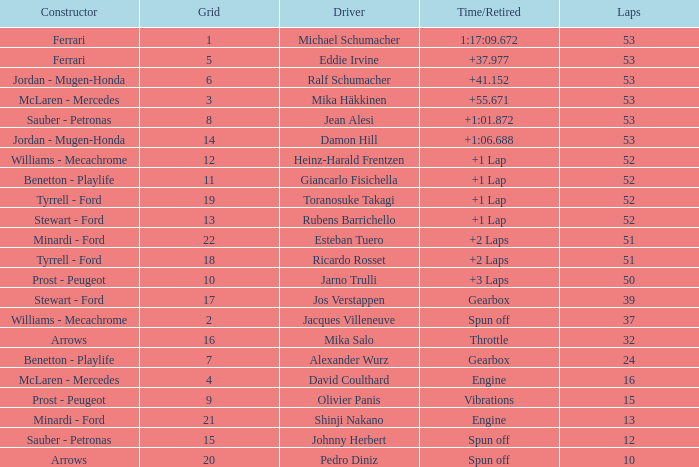Would you be able to parse every entry in this table? {'header': ['Constructor', 'Grid', 'Driver', 'Time/Retired', 'Laps'], 'rows': [['Ferrari', '1', 'Michael Schumacher', '1:17:09.672', '53'], ['Ferrari', '5', 'Eddie Irvine', '+37.977', '53'], ['Jordan - Mugen-Honda', '6', 'Ralf Schumacher', '+41.152', '53'], ['McLaren - Mercedes', '3', 'Mika Häkkinen', '+55.671', '53'], ['Sauber - Petronas', '8', 'Jean Alesi', '+1:01.872', '53'], ['Jordan - Mugen-Honda', '14', 'Damon Hill', '+1:06.688', '53'], ['Williams - Mecachrome', '12', 'Heinz-Harald Frentzen', '+1 Lap', '52'], ['Benetton - Playlife', '11', 'Giancarlo Fisichella', '+1 Lap', '52'], ['Tyrrell - Ford', '19', 'Toranosuke Takagi', '+1 Lap', '52'], ['Stewart - Ford', '13', 'Rubens Barrichello', '+1 Lap', '52'], ['Minardi - Ford', '22', 'Esteban Tuero', '+2 Laps', '51'], ['Tyrrell - Ford', '18', 'Ricardo Rosset', '+2 Laps', '51'], ['Prost - Peugeot', '10', 'Jarno Trulli', '+3 Laps', '50'], ['Stewart - Ford', '17', 'Jos Verstappen', 'Gearbox', '39'], ['Williams - Mecachrome', '2', 'Jacques Villeneuve', 'Spun off', '37'], ['Arrows', '16', 'Mika Salo', 'Throttle', '32'], ['Benetton - Playlife', '7', 'Alexander Wurz', 'Gearbox', '24'], ['McLaren - Mercedes', '4', 'David Coulthard', 'Engine', '16'], ['Prost - Peugeot', '9', 'Olivier Panis', 'Vibrations', '15'], ['Minardi - Ford', '21', 'Shinji Nakano', 'Engine', '13'], ['Sauber - Petronas', '15', 'Johnny Herbert', 'Spun off', '12'], ['Arrows', '20', 'Pedro Diniz', 'Spun off', '10']]} What is the high lap total for pedro diniz? 10.0. 